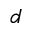Convert formula to latex. <formula><loc_0><loc_0><loc_500><loc_500>d</formula> 